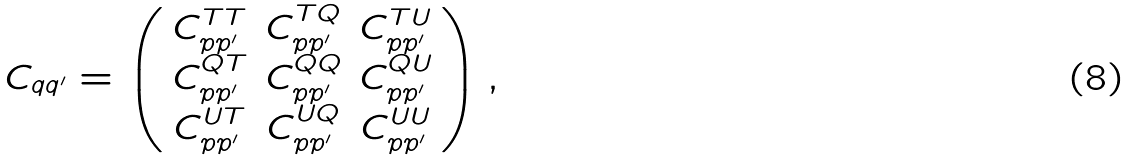<formula> <loc_0><loc_0><loc_500><loc_500>C _ { q q ^ { \prime } } = \left ( \begin{array} { c c c } C ^ { T T } _ { p p ^ { \prime } } & C ^ { T Q } _ { p p ^ { \prime } } & C ^ { T U } _ { p p ^ { \prime } } \\ C ^ { Q T } _ { p p ^ { \prime } } & C ^ { Q Q } _ { p p ^ { \prime } } & C ^ { Q U } _ { p p ^ { \prime } } \\ C ^ { U T } _ { p p ^ { \prime } } & C ^ { U Q } _ { p p ^ { \prime } } & C ^ { U U } _ { p p ^ { \prime } } \end{array} \right ) ,</formula> 